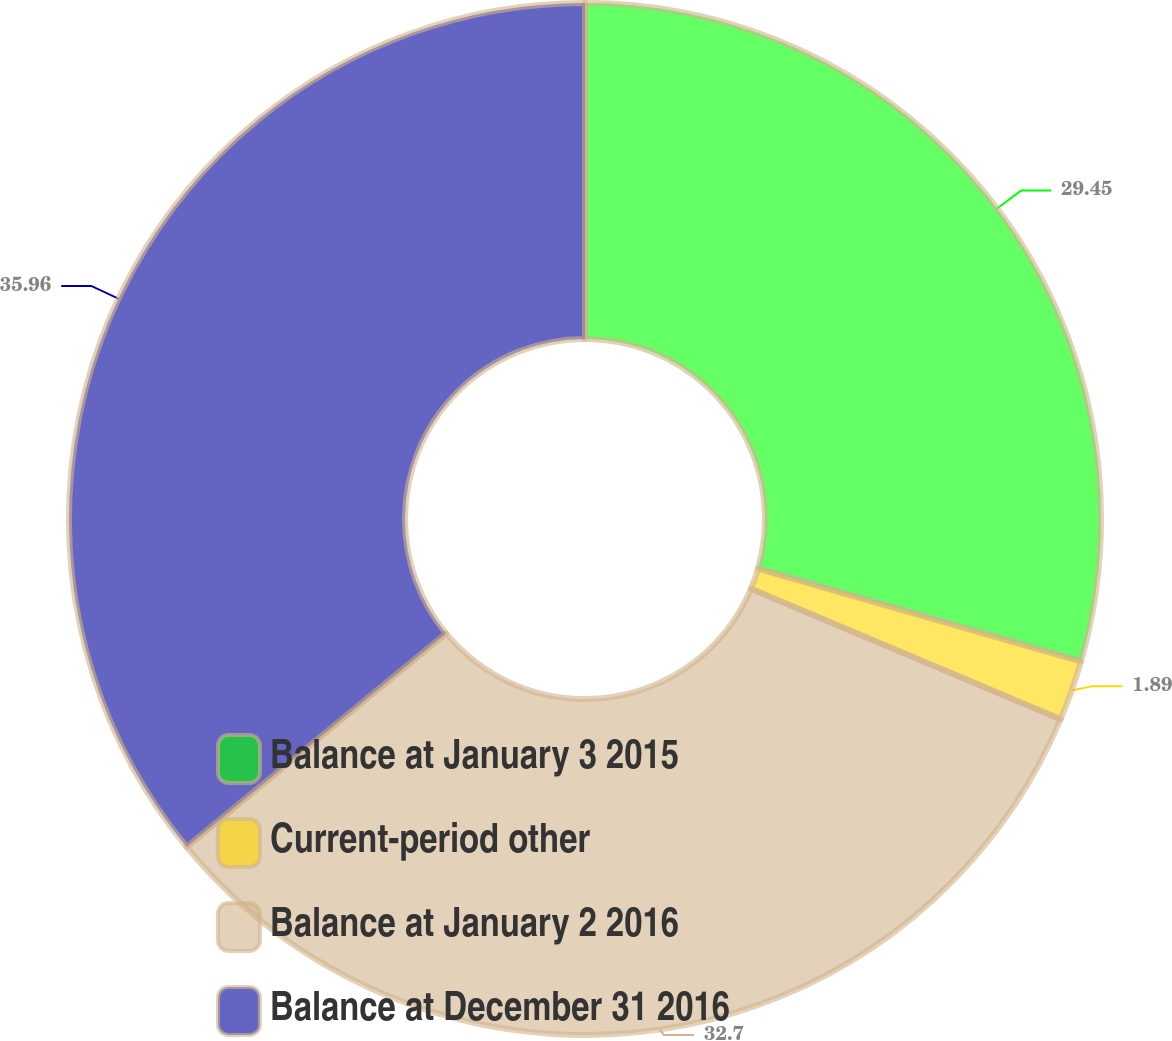<chart> <loc_0><loc_0><loc_500><loc_500><pie_chart><fcel>Balance at January 3 2015<fcel>Current-period other<fcel>Balance at January 2 2016<fcel>Balance at December 31 2016<nl><fcel>29.45%<fcel>1.89%<fcel>32.7%<fcel>35.96%<nl></chart> 